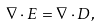Convert formula to latex. <formula><loc_0><loc_0><loc_500><loc_500>\nabla \cdot E = \nabla \cdot D ,</formula> 